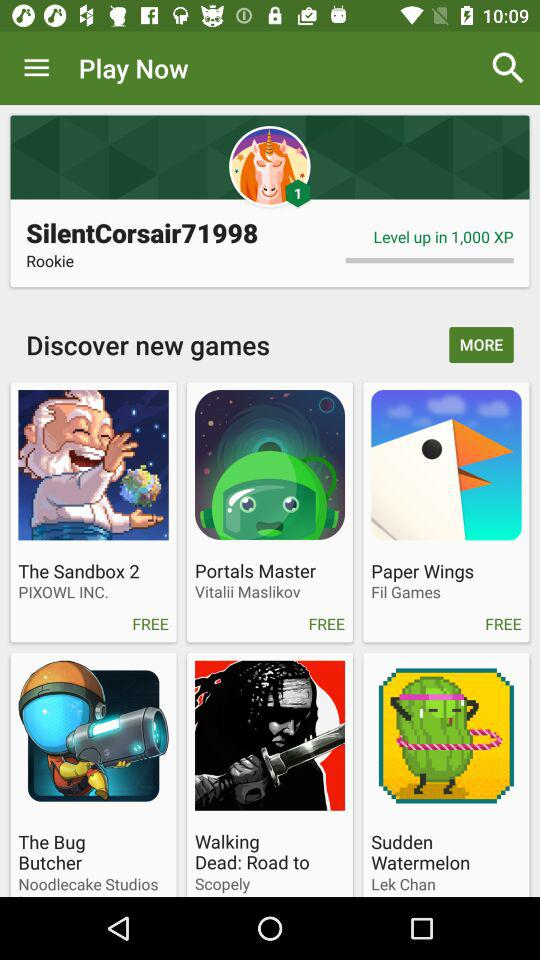What is the name of the user? The name of the user is SilentCorsair71998. 